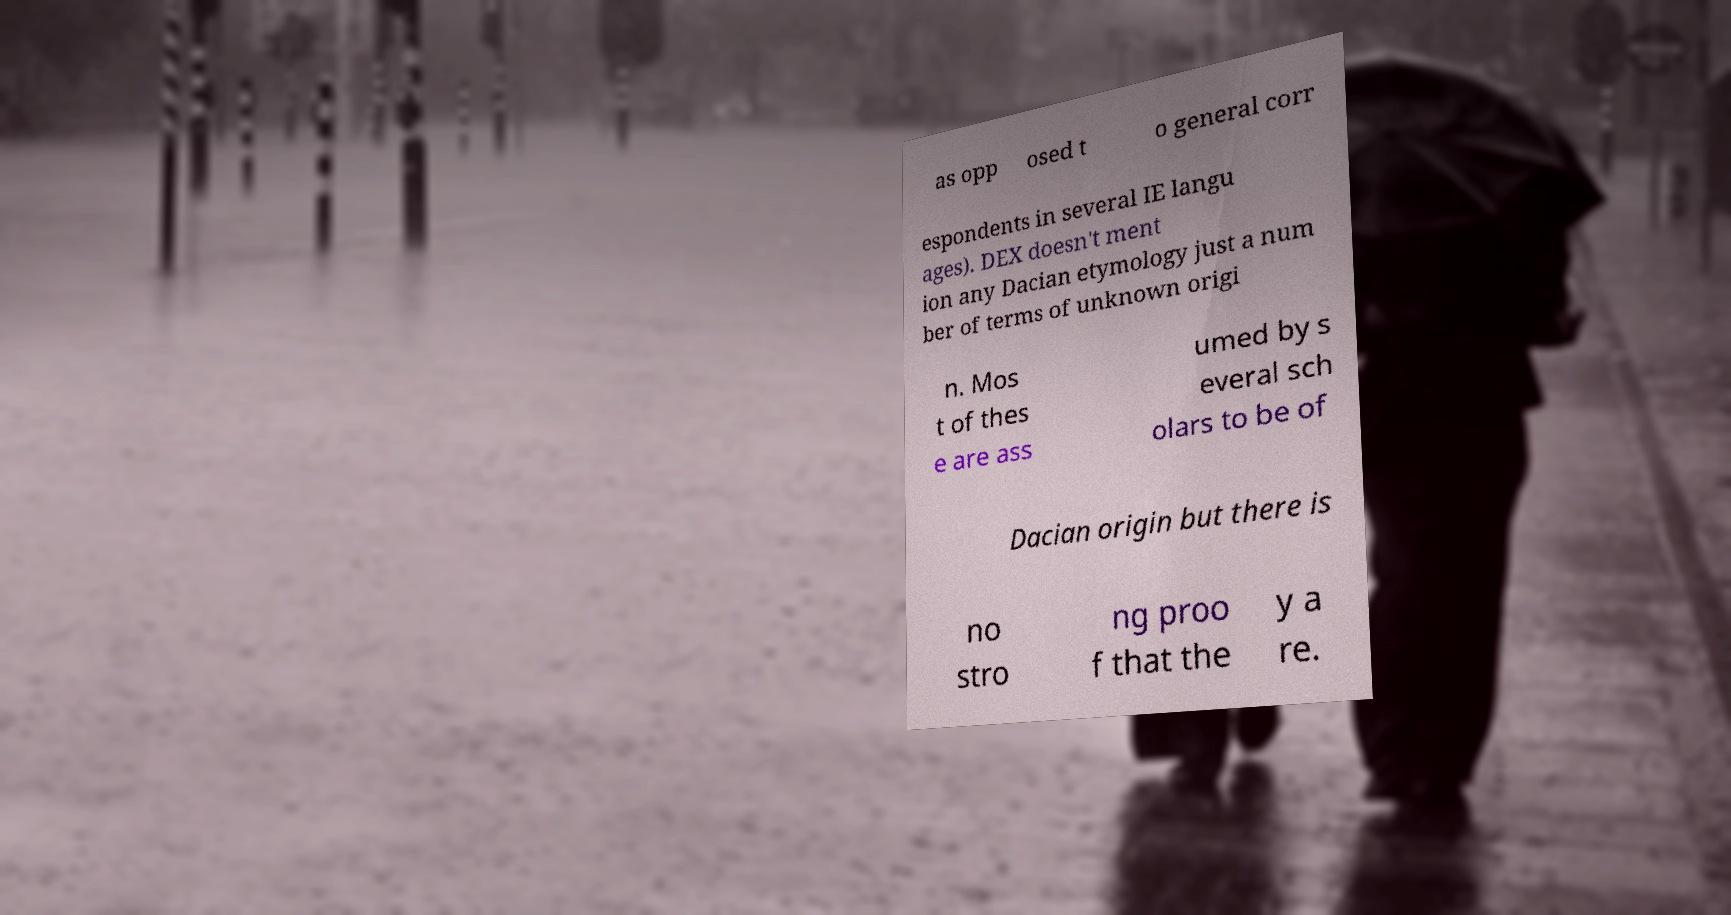Can you read and provide the text displayed in the image?This photo seems to have some interesting text. Can you extract and type it out for me? as opp osed t o general corr espondents in several IE langu ages). DEX doesn't ment ion any Dacian etymology just a num ber of terms of unknown origi n. Mos t of thes e are ass umed by s everal sch olars to be of Dacian origin but there is no stro ng proo f that the y a re. 